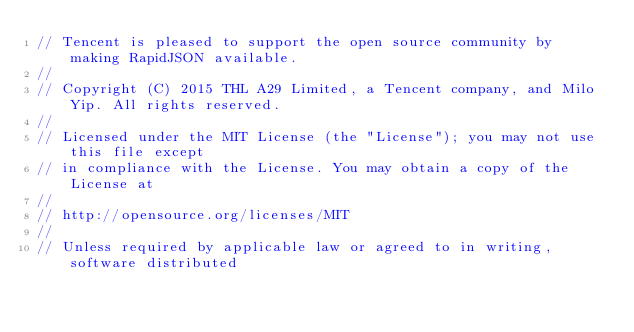Convert code to text. <code><loc_0><loc_0><loc_500><loc_500><_C_>// Tencent is pleased to support the open source community by making RapidJSON available.
// 
// Copyright (C) 2015 THL A29 Limited, a Tencent company, and Milo Yip. All rights reserved.
//
// Licensed under the MIT License (the "License"); you may not use this file except
// in compliance with the License. You may obtain a copy of the License at
//
// http://opensource.org/licenses/MIT
//
// Unless required by applicable law or agreed to in writing, software distributed </code> 